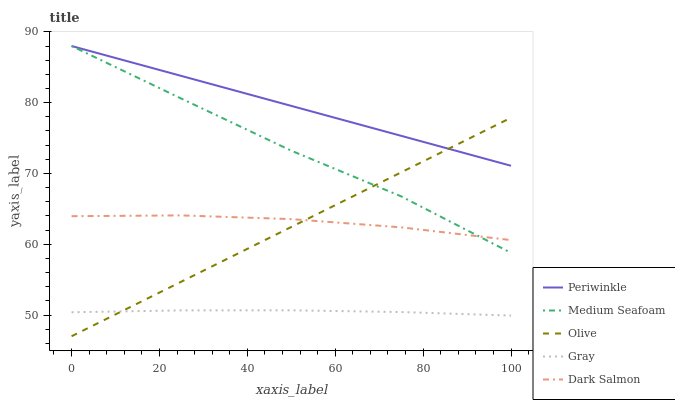Does Gray have the minimum area under the curve?
Answer yes or no. Yes. Does Periwinkle have the maximum area under the curve?
Answer yes or no. Yes. Does Periwinkle have the minimum area under the curve?
Answer yes or no. No. Does Gray have the maximum area under the curve?
Answer yes or no. No. Is Olive the smoothest?
Answer yes or no. Yes. Is Medium Seafoam the roughest?
Answer yes or no. Yes. Is Gray the smoothest?
Answer yes or no. No. Is Gray the roughest?
Answer yes or no. No. Does Olive have the lowest value?
Answer yes or no. Yes. Does Gray have the lowest value?
Answer yes or no. No. Does Medium Seafoam have the highest value?
Answer yes or no. Yes. Does Gray have the highest value?
Answer yes or no. No. Is Dark Salmon less than Periwinkle?
Answer yes or no. Yes. Is Periwinkle greater than Gray?
Answer yes or no. Yes. Does Periwinkle intersect Medium Seafoam?
Answer yes or no. Yes. Is Periwinkle less than Medium Seafoam?
Answer yes or no. No. Is Periwinkle greater than Medium Seafoam?
Answer yes or no. No. Does Dark Salmon intersect Periwinkle?
Answer yes or no. No. 